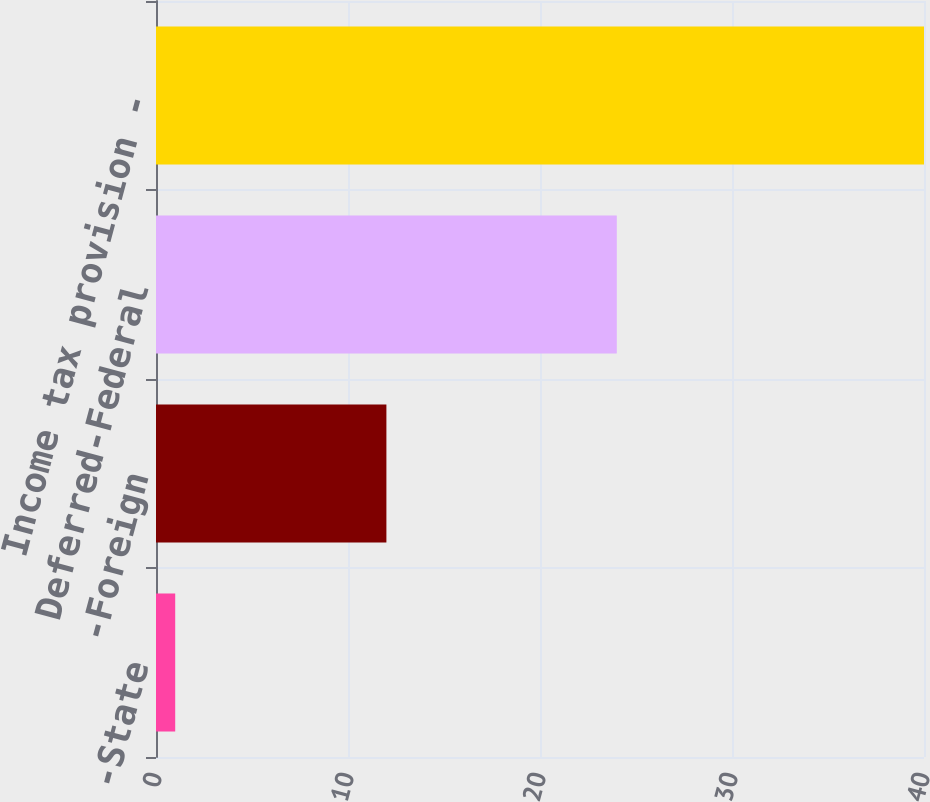Convert chart. <chart><loc_0><loc_0><loc_500><loc_500><bar_chart><fcel>-State<fcel>-Foreign<fcel>Deferred-Federal<fcel>Income tax provision -<nl><fcel>1<fcel>12<fcel>24<fcel>40<nl></chart> 